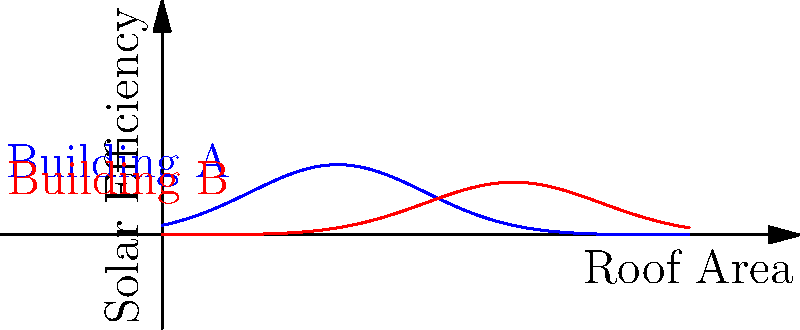Given the solar efficiency curves for two buildings in your affordable housing project, which building would you prioritize for solar panel installation to maximize energy output while minimizing costs? To determine which building to prioritize for solar panel installation, we need to analyze the solar efficiency curves:

1. Curve shape: Both curves are Gaussian (bell-shaped), representing solar efficiency across the roof area.

2. Peak efficiency:
   - Building A (blue): Peak efficiency ≈ 0.8
   - Building B (red): Peak efficiency ≈ 0.6

3. Optimal roof area:
   - Building A: Peak at x ≈ 2
   - Building B: Peak at x ≈ 4

4. Curve width:
   - Building A has a narrower curve
   - Building B has a wider curve

5. Analysis:
   - Building A has higher peak efficiency (0.8 vs 0.6)
   - Building A requires less roof area to achieve peak efficiency (2 vs 4)
   - Building A's narrower curve suggests more precise panel placement is needed

6. Decision factors:
   - Higher efficiency means more energy output per panel
   - Less roof area needed reduces installation costs
   - More precise placement may increase installation complexity

Considering these factors, Building A offers higher efficiency and requires less roof area, which aligns with the goal of maximizing energy output while minimizing costs.
Answer: Building A 